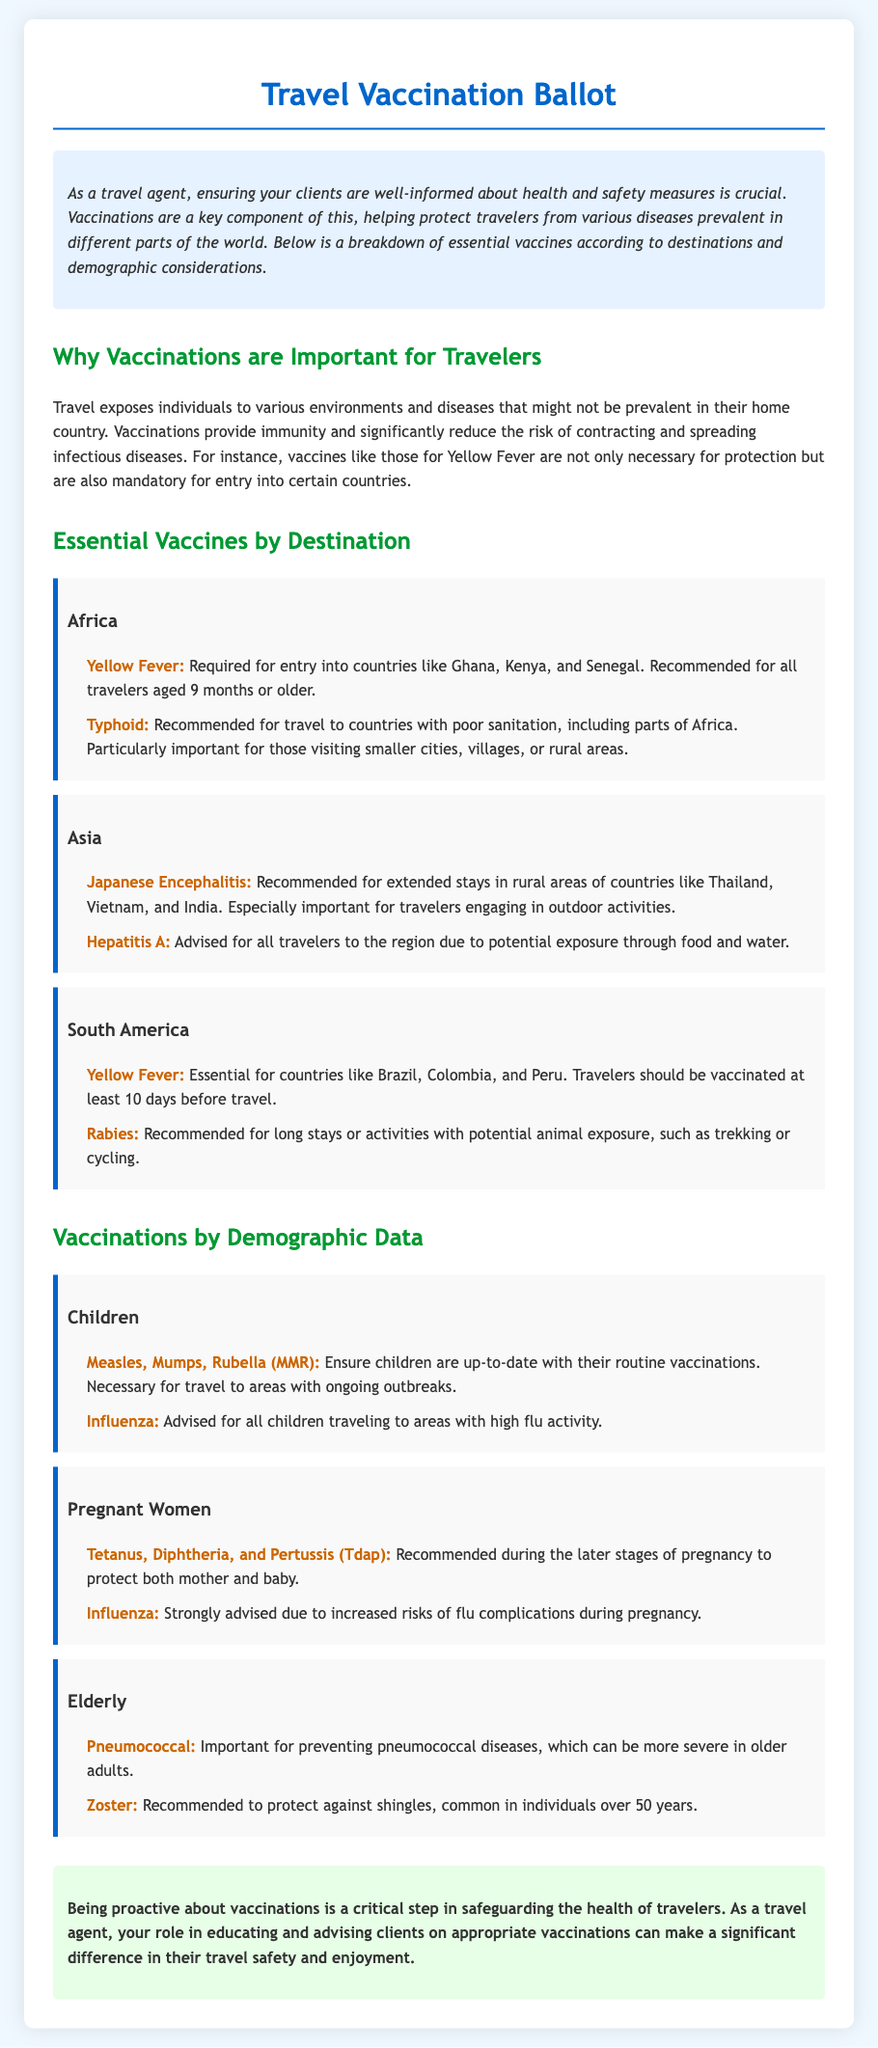What are the essential vaccines for travelers to Africa? The document states that essential vaccines for travelers to Africa include Yellow Fever and Typhoid.
Answer: Yellow Fever, Typhoid Which vaccine is required for entry into Ghana? The document mentions that Yellow Fever is required for entry into countries like Ghana.
Answer: Yellow Fever What age group is recommended to receive the Yellow Fever vaccine? The document specifies that the Yellow Fever vaccine is recommended for all travelers aged 9 months or older.
Answer: 9 months or older Why are vaccinations critical for travelers? According to the document, vaccinations provide immunity and significantly reduce the risk of contracting and spreading infectious diseases.
Answer: Immunity and risk reduction What should travelers to rural areas of Thailand be vaccinated against? The document recommends the Japanese Encephalitis vaccine for travelers engaging in outdoor activities in rural areas of Thailand.
Answer: Japanese Encephalitis Which vaccine is advised for pregnant women during later stages of pregnancy? The document states that the Tetanus, Diphtheria, and Pertussis (Tdap) vaccine is recommended for pregnant women.
Answer: Tdap What vaccine is highlighted for elderly travelers? The document identifies the Pneumococcal vaccine as important for preventing pneumococcal diseases in older adults.
Answer: Pneumococcal How many vaccines are mentioned for children in the document? The document lists two vaccines specifically for children: Measles, Mumps, Rubella (MMR) and Influenza.
Answer: Two What is a recommended timeframe for the Yellow Fever vaccine before travel? The document advises travelers to be vaccinated at least 10 days before travel for the Yellow Fever vaccine.
Answer: 10 days 